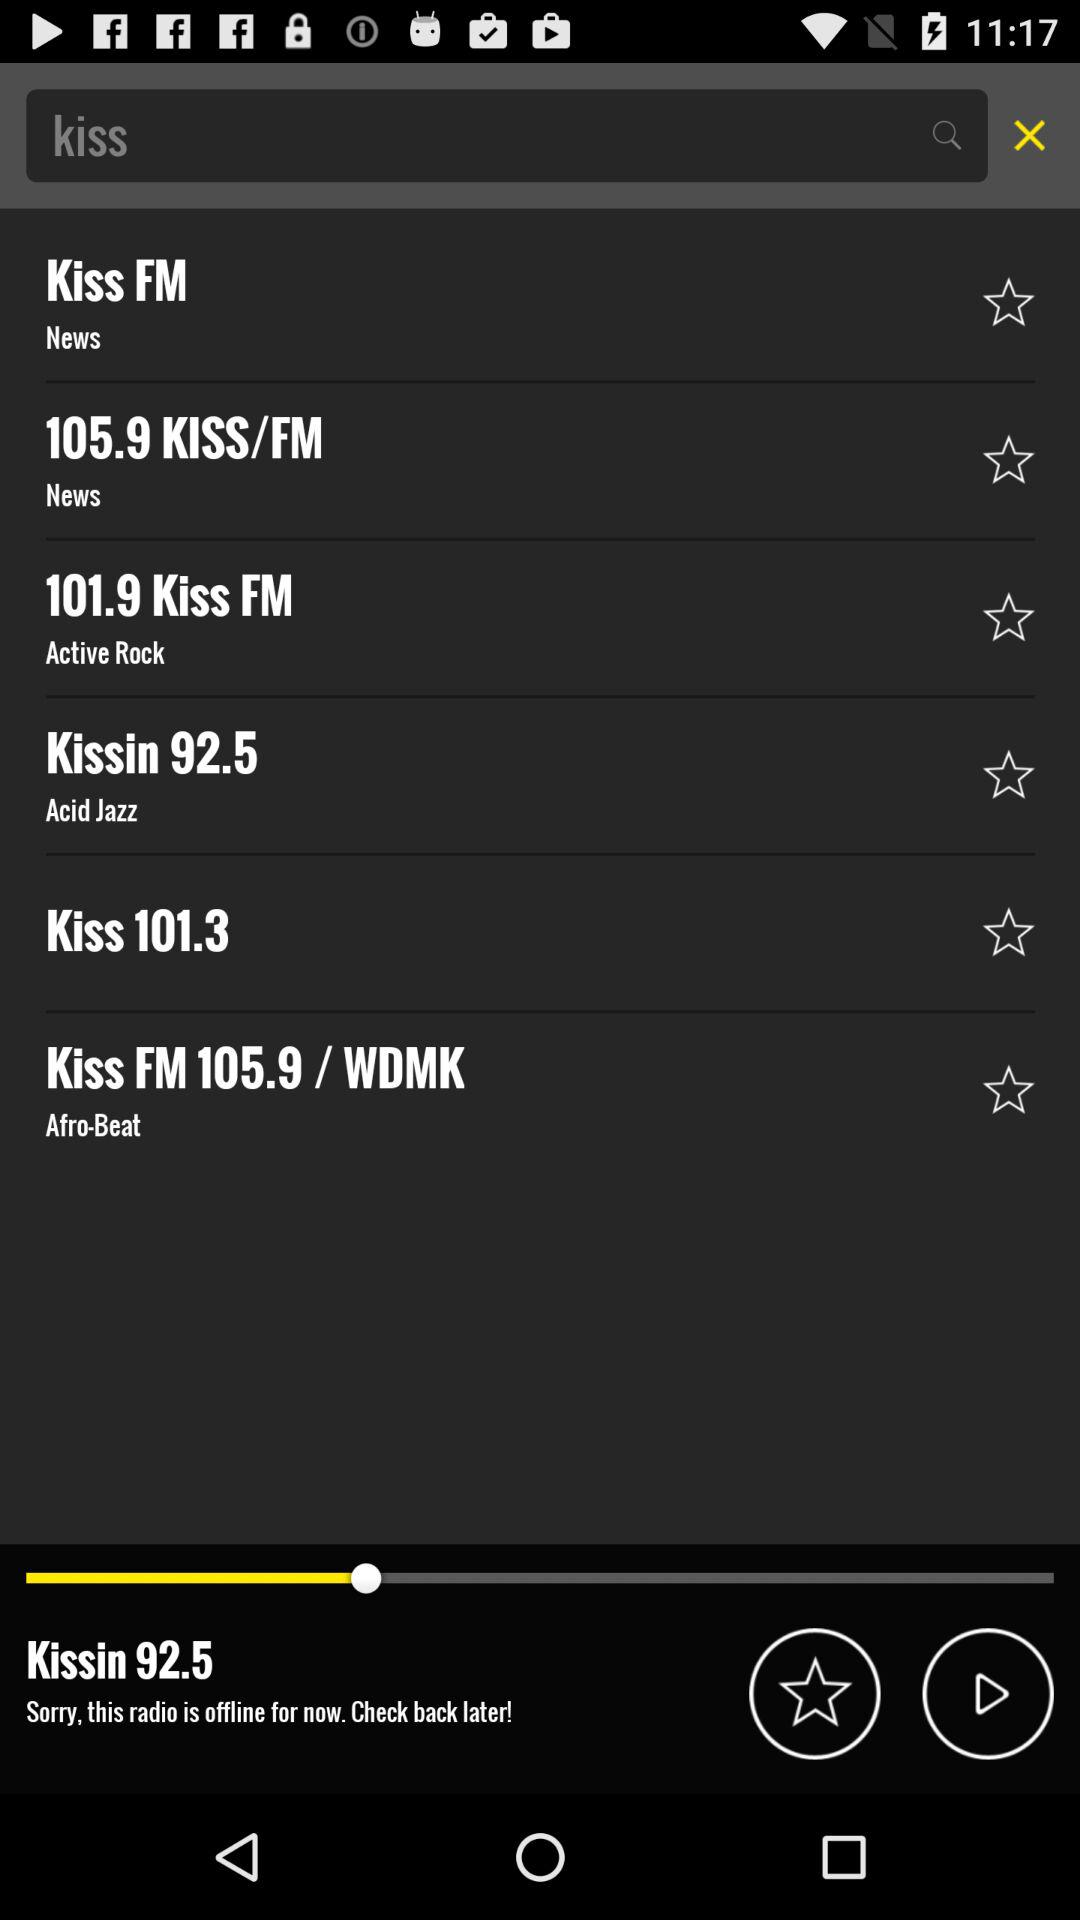What are the options for FM? The options for FM are "Kiss FM", "105.9 KISS/FM", "101.9 Kiss FM", "Kissin 92.5", "Kiss 101.3" and "Kiss FM 105.9 / WDMK". 